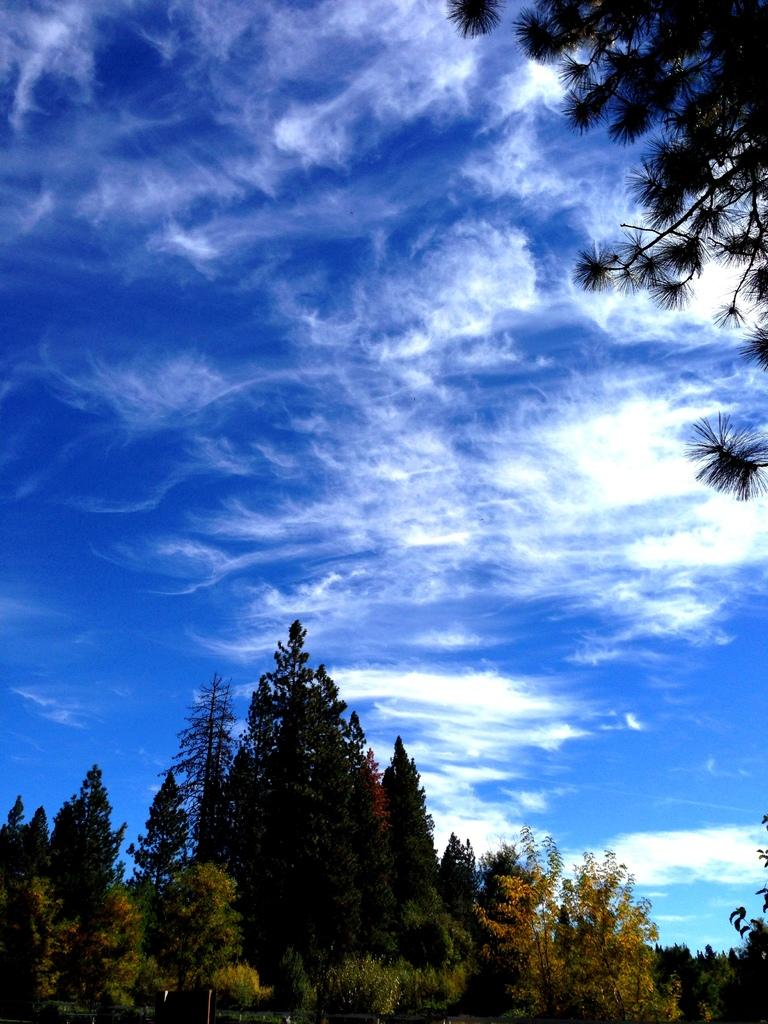What type of vegetation can be seen in the image? There are trees in the image. What can be seen in the sky in the image? There are clouds in the image. What type of steel is used to construct the writer's desk in the image? There is no writer or desk present in the image; it only features trees and clouds. What type of test is being conducted on the trees in the image? There is no test being conducted on the trees in the image; they are simply depicted as part of the natural environment. 